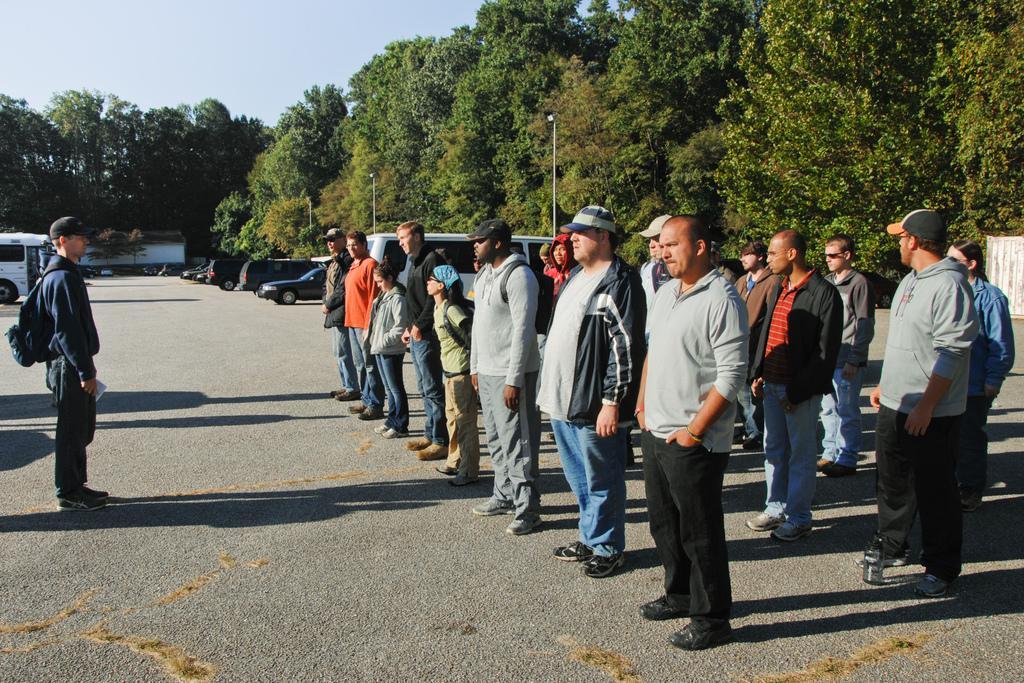Describe this image in one or two sentences. This image consists of many people standing in a line on the road. To the left, the man is wearing a backpack. In the background, there are many vehicles parked on the road. And there are many trees. At the top, there is a sky. At the bottom, there is a road. 